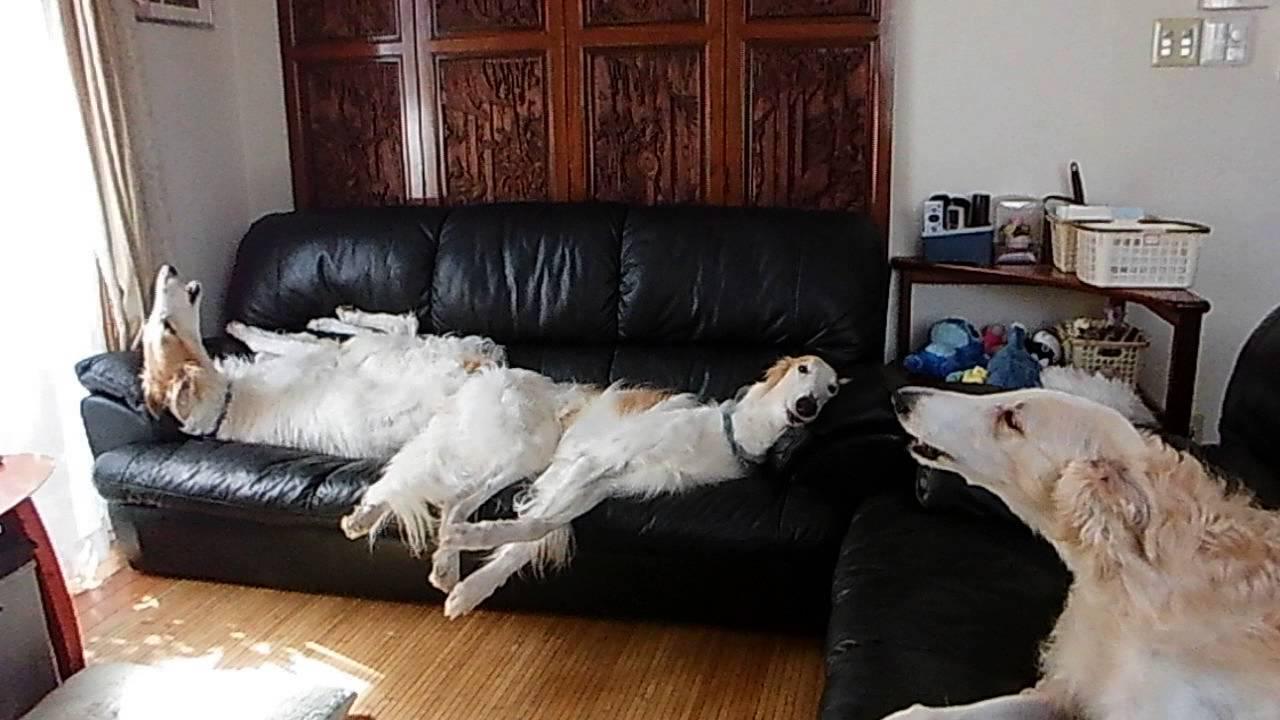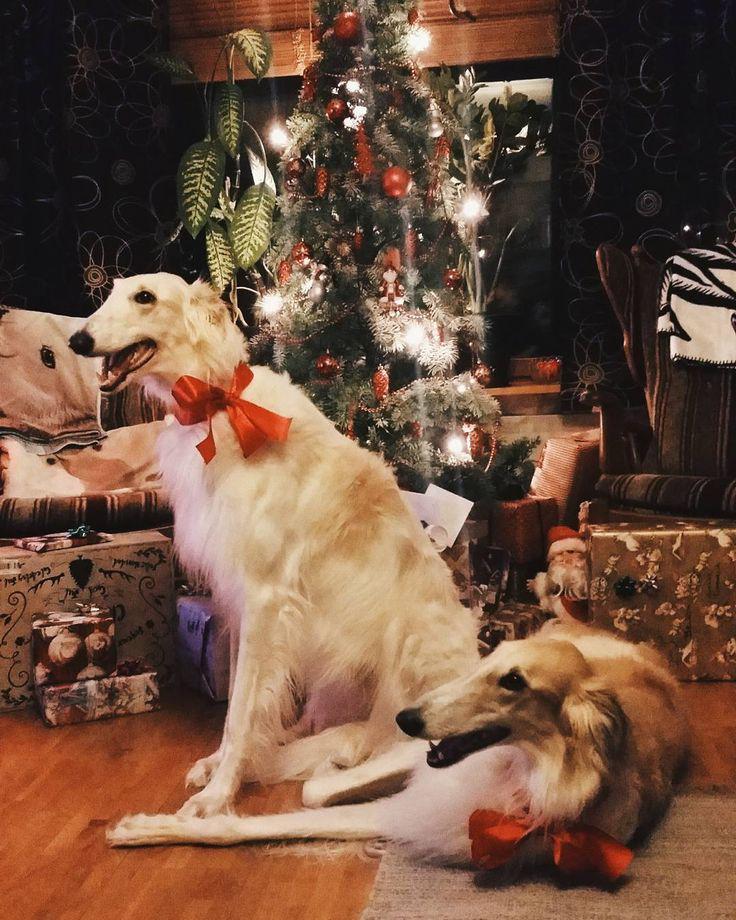The first image is the image on the left, the second image is the image on the right. Evaluate the accuracy of this statement regarding the images: "There is at least one Borzoi dog lying on a couch.". Is it true? Answer yes or no. Yes. The first image is the image on the left, the second image is the image on the right. Evaluate the accuracy of this statement regarding the images: "One image shows at least one dog reclining on a dark sofa with its muzzle pointed upward and its mouth slightly opened.". Is it true? Answer yes or no. Yes. 